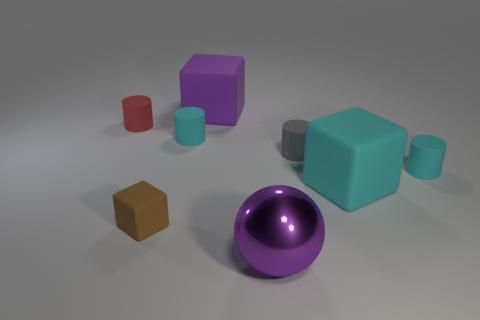What number of matte things are the same color as the large metallic sphere?
Your answer should be very brief. 1. There is a big block on the left side of the tiny gray matte cylinder; what material is it?
Provide a succinct answer. Rubber. What number of things are either large rubber cubes on the right side of the large shiny sphere or matte objects to the right of the tiny brown thing?
Give a very brief answer. 5. What is the material of the big cyan thing that is the same shape as the tiny brown thing?
Your answer should be very brief. Rubber. Do the big matte thing that is in front of the red rubber cylinder and the cylinder that is right of the big cyan matte block have the same color?
Keep it short and to the point. Yes. Are there any objects that have the same size as the metal ball?
Your answer should be compact. Yes. The large thing that is both in front of the gray rubber cylinder and on the left side of the gray cylinder is made of what material?
Your response must be concise. Metal. What number of rubber objects are either small brown cubes or blocks?
Provide a succinct answer. 3. What shape is the tiny gray thing that is the same material as the big purple block?
Offer a terse response. Cylinder. What number of cyan rubber objects are both behind the big cyan block and right of the tiny gray cylinder?
Ensure brevity in your answer.  1. 